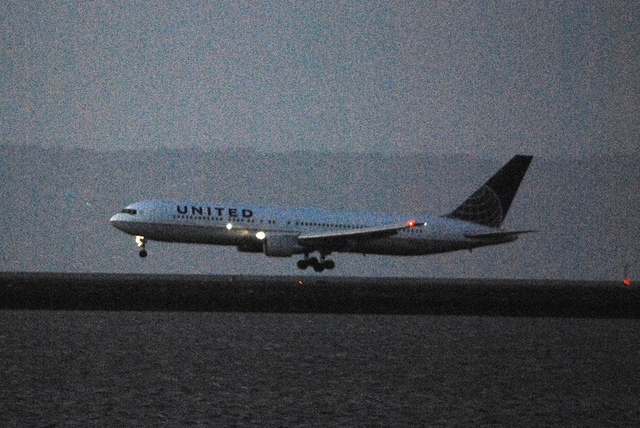Describe the objects in this image and their specific colors. I can see a airplane in gray and black tones in this image. 